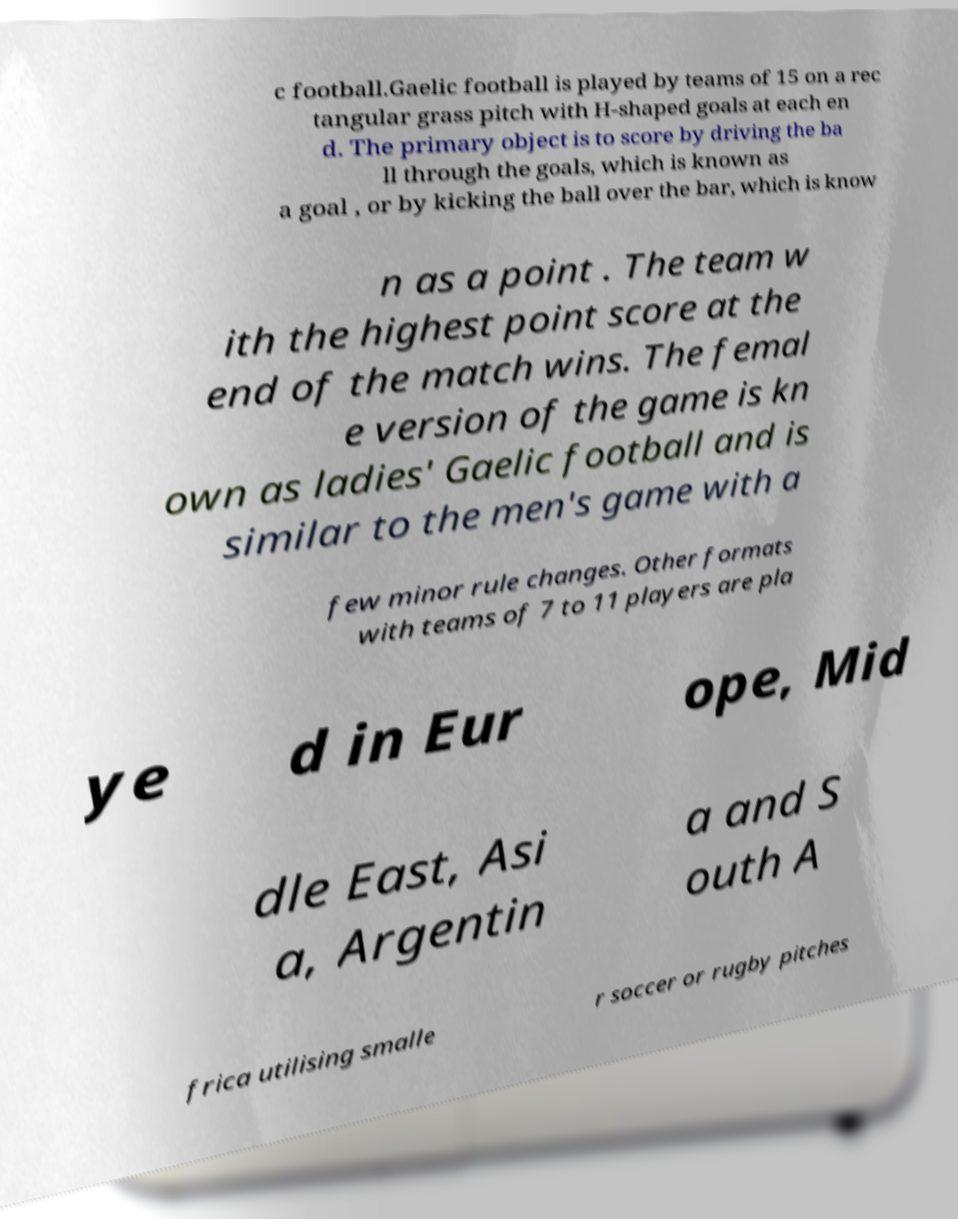Can you read and provide the text displayed in the image?This photo seems to have some interesting text. Can you extract and type it out for me? c football.Gaelic football is played by teams of 15 on a rec tangular grass pitch with H-shaped goals at each en d. The primary object is to score by driving the ba ll through the goals, which is known as a goal , or by kicking the ball over the bar, which is know n as a point . The team w ith the highest point score at the end of the match wins. The femal e version of the game is kn own as ladies' Gaelic football and is similar to the men's game with a few minor rule changes. Other formats with teams of 7 to 11 players are pla ye d in Eur ope, Mid dle East, Asi a, Argentin a and S outh A frica utilising smalle r soccer or rugby pitches 